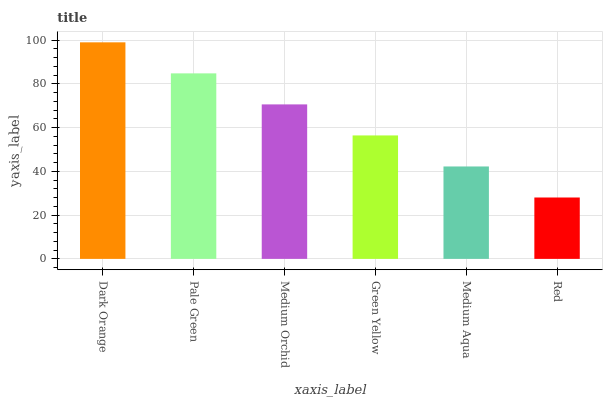Is Red the minimum?
Answer yes or no. Yes. Is Dark Orange the maximum?
Answer yes or no. Yes. Is Pale Green the minimum?
Answer yes or no. No. Is Pale Green the maximum?
Answer yes or no. No. Is Dark Orange greater than Pale Green?
Answer yes or no. Yes. Is Pale Green less than Dark Orange?
Answer yes or no. Yes. Is Pale Green greater than Dark Orange?
Answer yes or no. No. Is Dark Orange less than Pale Green?
Answer yes or no. No. Is Medium Orchid the high median?
Answer yes or no. Yes. Is Green Yellow the low median?
Answer yes or no. Yes. Is Green Yellow the high median?
Answer yes or no. No. Is Dark Orange the low median?
Answer yes or no. No. 